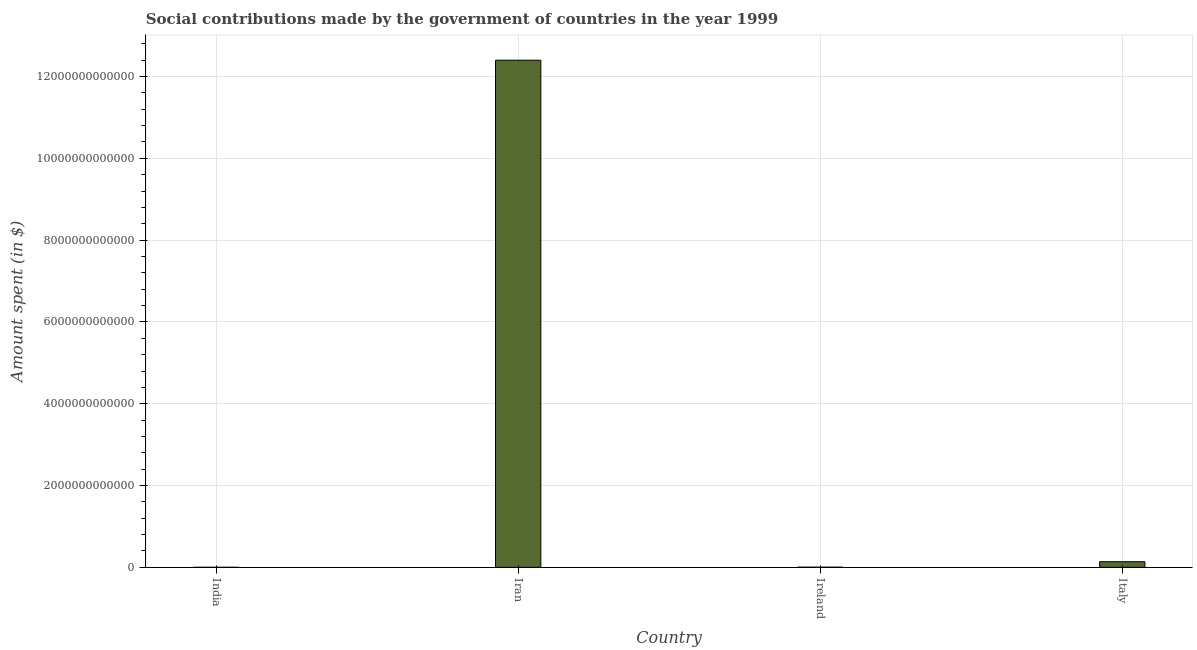Does the graph contain any zero values?
Give a very brief answer. No. Does the graph contain grids?
Provide a succinct answer. Yes. What is the title of the graph?
Ensure brevity in your answer.  Social contributions made by the government of countries in the year 1999. What is the label or title of the X-axis?
Give a very brief answer. Country. What is the label or title of the Y-axis?
Provide a short and direct response. Amount spent (in $). What is the amount spent in making social contributions in Ireland?
Give a very brief answer. 4.55e+09. Across all countries, what is the maximum amount spent in making social contributions?
Offer a very short reply. 1.24e+13. Across all countries, what is the minimum amount spent in making social contributions?
Ensure brevity in your answer.  1.45e+09. In which country was the amount spent in making social contributions maximum?
Make the answer very short. Iran. What is the sum of the amount spent in making social contributions?
Offer a very short reply. 1.25e+13. What is the difference between the amount spent in making social contributions in Ireland and Italy?
Provide a succinct answer. -1.33e+11. What is the average amount spent in making social contributions per country?
Your response must be concise. 3.14e+12. What is the median amount spent in making social contributions?
Give a very brief answer. 7.11e+1. In how many countries, is the amount spent in making social contributions greater than 4800000000000 $?
Make the answer very short. 1. What is the ratio of the amount spent in making social contributions in Iran to that in Ireland?
Offer a very short reply. 2726.64. What is the difference between the highest and the second highest amount spent in making social contributions?
Your answer should be very brief. 1.23e+13. Is the sum of the amount spent in making social contributions in Ireland and Italy greater than the maximum amount spent in making social contributions across all countries?
Ensure brevity in your answer.  No. What is the difference between the highest and the lowest amount spent in making social contributions?
Ensure brevity in your answer.  1.24e+13. Are all the bars in the graph horizontal?
Keep it short and to the point. No. How many countries are there in the graph?
Provide a succinct answer. 4. What is the difference between two consecutive major ticks on the Y-axis?
Give a very brief answer. 2.00e+12. Are the values on the major ticks of Y-axis written in scientific E-notation?
Offer a terse response. No. What is the Amount spent (in $) of India?
Provide a short and direct response. 1.45e+09. What is the Amount spent (in $) in Iran?
Make the answer very short. 1.24e+13. What is the Amount spent (in $) of Ireland?
Provide a succinct answer. 4.55e+09. What is the Amount spent (in $) of Italy?
Offer a very short reply. 1.38e+11. What is the difference between the Amount spent (in $) in India and Iran?
Your answer should be very brief. -1.24e+13. What is the difference between the Amount spent (in $) in India and Ireland?
Ensure brevity in your answer.  -3.10e+09. What is the difference between the Amount spent (in $) in India and Italy?
Your answer should be compact. -1.36e+11. What is the difference between the Amount spent (in $) in Iran and Ireland?
Provide a short and direct response. 1.24e+13. What is the difference between the Amount spent (in $) in Iran and Italy?
Give a very brief answer. 1.23e+13. What is the difference between the Amount spent (in $) in Ireland and Italy?
Ensure brevity in your answer.  -1.33e+11. What is the ratio of the Amount spent (in $) in India to that in Ireland?
Keep it short and to the point. 0.32. What is the ratio of the Amount spent (in $) in India to that in Italy?
Ensure brevity in your answer.  0.01. What is the ratio of the Amount spent (in $) in Iran to that in Ireland?
Provide a short and direct response. 2726.64. What is the ratio of the Amount spent (in $) in Iran to that in Italy?
Ensure brevity in your answer.  90.12. What is the ratio of the Amount spent (in $) in Ireland to that in Italy?
Your answer should be compact. 0.03. 